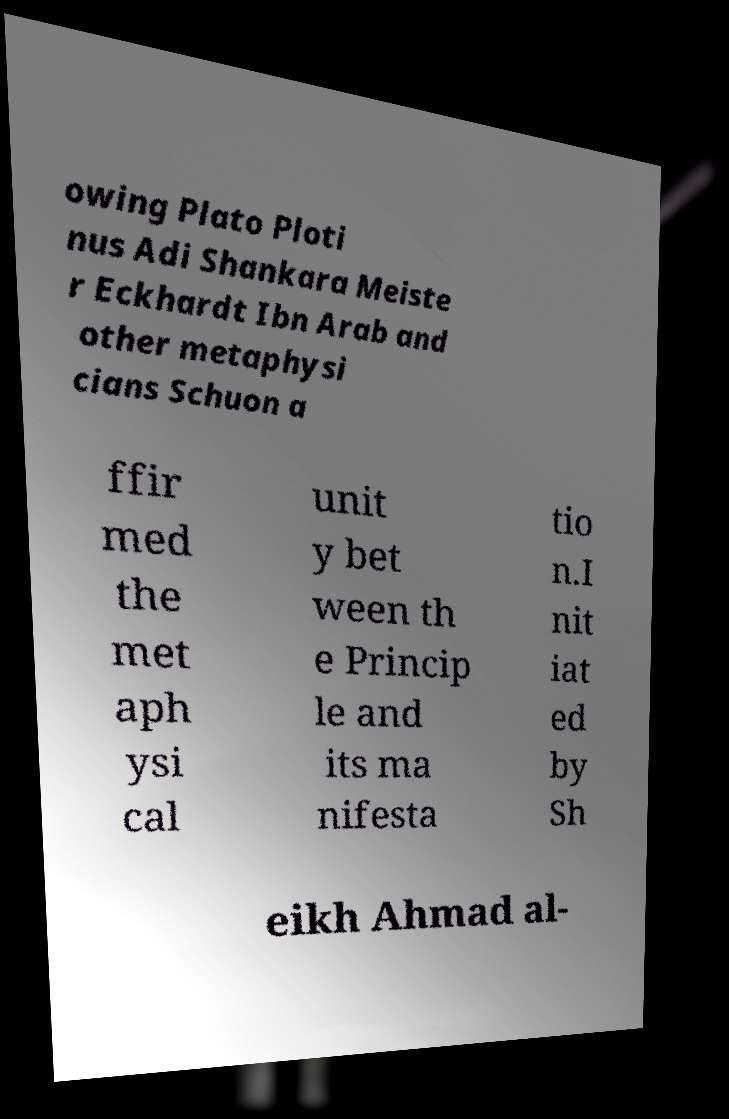Please identify and transcribe the text found in this image. owing Plato Ploti nus Adi Shankara Meiste r Eckhardt Ibn Arab and other metaphysi cians Schuon a ffir med the met aph ysi cal unit y bet ween th e Princip le and its ma nifesta tio n.I nit iat ed by Sh eikh Ahmad al- 